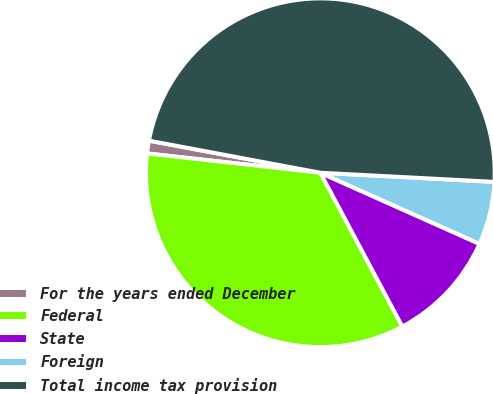<chart> <loc_0><loc_0><loc_500><loc_500><pie_chart><fcel>For the years ended December<fcel>Federal<fcel>State<fcel>Foreign<fcel>Total income tax provision<nl><fcel>1.18%<fcel>34.56%<fcel>10.52%<fcel>5.85%<fcel>47.89%<nl></chart> 